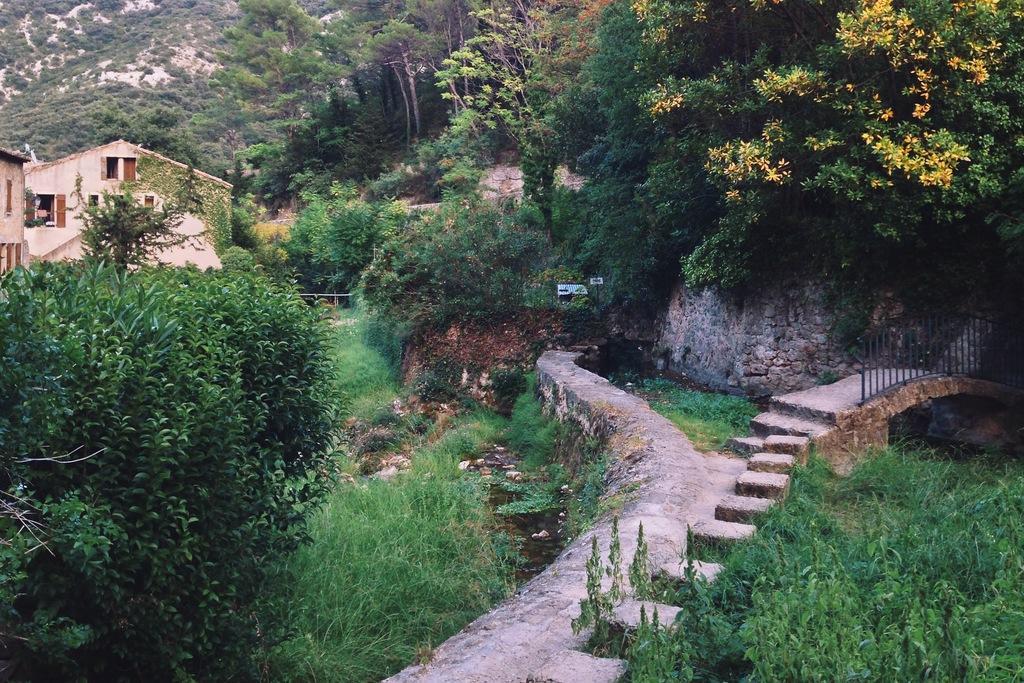How would you summarize this image in a sentence or two? In this image we can see trees and houses, to the right of the image we can see a metal rod fence. 